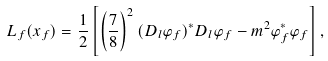<formula> <loc_0><loc_0><loc_500><loc_500>L _ { f } ( x _ { f } ) = \frac { 1 } { 2 } \left [ \left ( \frac { 7 } { 8 } \right ) ^ { 2 } ( D _ { l } \varphi _ { f } ) ^ { * } D _ { l } \varphi _ { f } - m ^ { 2 } \varphi _ { f } ^ { * } \varphi _ { f } \right ] ,</formula> 